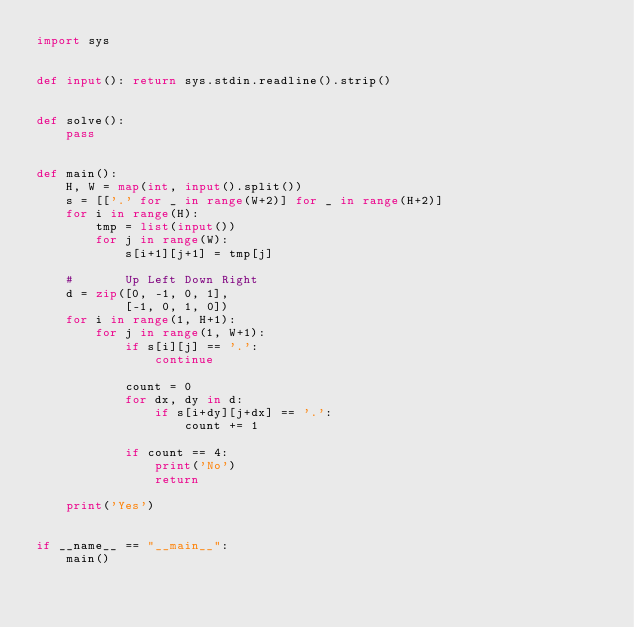Convert code to text. <code><loc_0><loc_0><loc_500><loc_500><_Python_>import sys


def input(): return sys.stdin.readline().strip()


def solve():
    pass


def main():
    H, W = map(int, input().split())
    s = [['.' for _ in range(W+2)] for _ in range(H+2)]
    for i in range(H):
        tmp = list(input())
        for j in range(W):
            s[i+1][j+1] = tmp[j]

    #       Up Left Down Right
    d = zip([0, -1, 0, 1],
            [-1, 0, 1, 0])
    for i in range(1, H+1):
        for j in range(1, W+1):
            if s[i][j] == '.':
                continue

            count = 0
            for dx, dy in d:
                if s[i+dy][j+dx] == '.':
                    count += 1

            if count == 4:
                print('No')
                return

    print('Yes')


if __name__ == "__main__":
    main()
</code> 